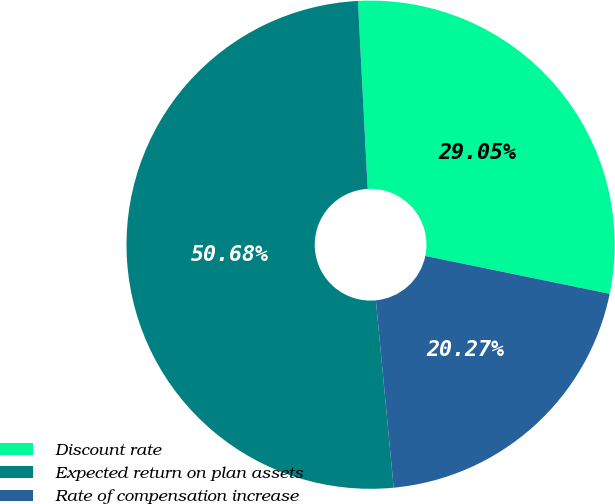Convert chart. <chart><loc_0><loc_0><loc_500><loc_500><pie_chart><fcel>Discount rate<fcel>Expected return on plan assets<fcel>Rate of compensation increase<nl><fcel>29.05%<fcel>50.68%<fcel>20.27%<nl></chart> 